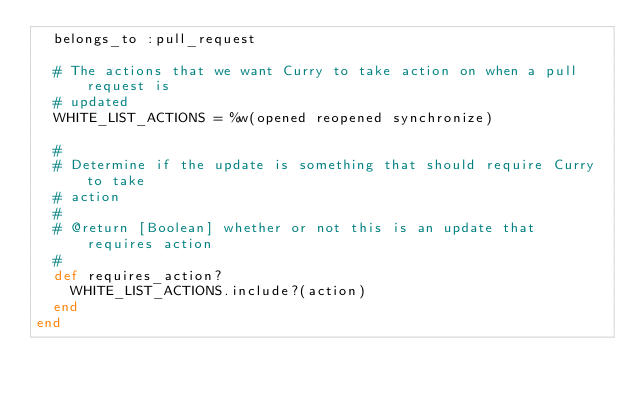Convert code to text. <code><loc_0><loc_0><loc_500><loc_500><_Ruby_>  belongs_to :pull_request

  # The actions that we want Curry to take action on when a pull request is
  # updated
  WHITE_LIST_ACTIONS = %w(opened reopened synchronize)

  #
  # Determine if the update is something that should require Curry to take
  # action
  #
  # @return [Boolean] whether or not this is an update that requires action
  #
  def requires_action?
    WHITE_LIST_ACTIONS.include?(action)
  end
end
</code> 